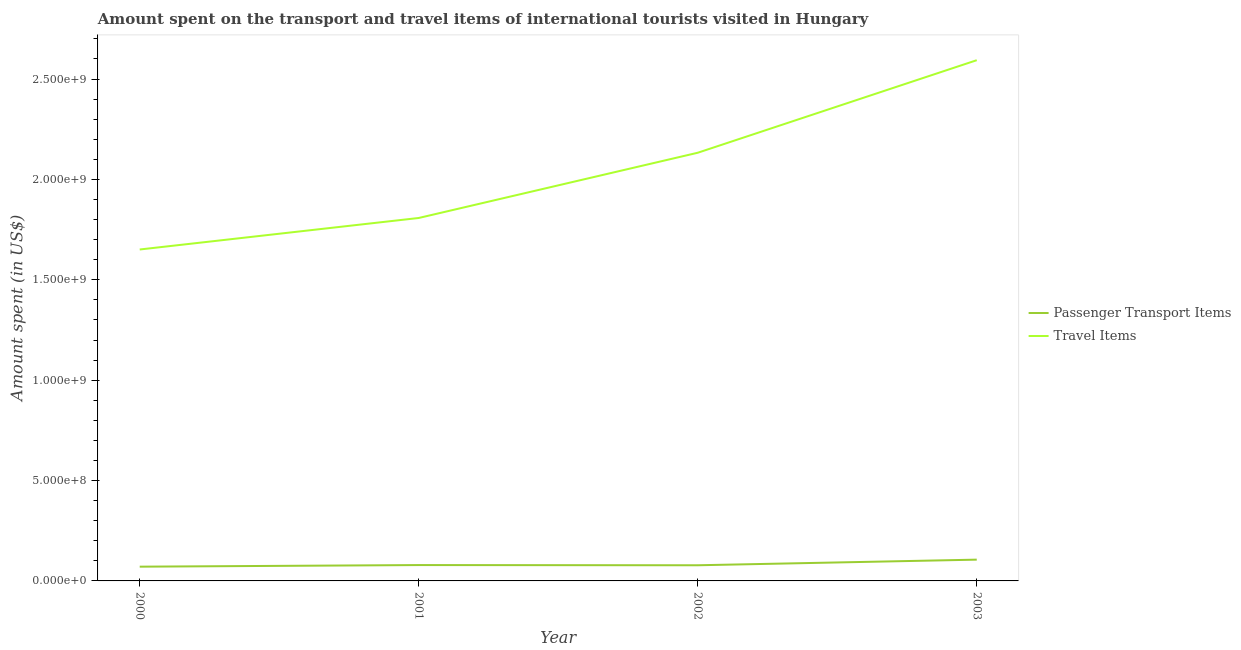Does the line corresponding to amount spent in travel items intersect with the line corresponding to amount spent on passenger transport items?
Provide a short and direct response. No. Is the number of lines equal to the number of legend labels?
Your answer should be compact. Yes. What is the amount spent on passenger transport items in 2002?
Provide a succinct answer. 7.80e+07. Across all years, what is the maximum amount spent on passenger transport items?
Offer a terse response. 1.06e+08. Across all years, what is the minimum amount spent in travel items?
Offer a terse response. 1.65e+09. In which year was the amount spent in travel items minimum?
Your answer should be very brief. 2000. What is the total amount spent on passenger transport items in the graph?
Your answer should be very brief. 3.34e+08. What is the difference between the amount spent on passenger transport items in 2002 and that in 2003?
Offer a terse response. -2.80e+07. What is the difference between the amount spent on passenger transport items in 2002 and the amount spent in travel items in 2000?
Offer a very short reply. -1.57e+09. What is the average amount spent on passenger transport items per year?
Ensure brevity in your answer.  8.35e+07. In the year 2000, what is the difference between the amount spent on passenger transport items and amount spent in travel items?
Your answer should be compact. -1.58e+09. What is the ratio of the amount spent in travel items in 2000 to that in 2001?
Provide a succinct answer. 0.91. Is the amount spent on passenger transport items in 2000 less than that in 2002?
Keep it short and to the point. Yes. What is the difference between the highest and the second highest amount spent on passenger transport items?
Your response must be concise. 2.70e+07. What is the difference between the highest and the lowest amount spent in travel items?
Keep it short and to the point. 9.43e+08. How many years are there in the graph?
Your response must be concise. 4. What is the difference between two consecutive major ticks on the Y-axis?
Your answer should be very brief. 5.00e+08. Are the values on the major ticks of Y-axis written in scientific E-notation?
Provide a succinct answer. Yes. Does the graph contain any zero values?
Ensure brevity in your answer.  No. Does the graph contain grids?
Give a very brief answer. No. How are the legend labels stacked?
Give a very brief answer. Vertical. What is the title of the graph?
Offer a very short reply. Amount spent on the transport and travel items of international tourists visited in Hungary. Does "Investment" appear as one of the legend labels in the graph?
Offer a very short reply. No. What is the label or title of the X-axis?
Make the answer very short. Year. What is the label or title of the Y-axis?
Your answer should be compact. Amount spent (in US$). What is the Amount spent (in US$) in Passenger Transport Items in 2000?
Offer a very short reply. 7.10e+07. What is the Amount spent (in US$) in Travel Items in 2000?
Make the answer very short. 1.65e+09. What is the Amount spent (in US$) in Passenger Transport Items in 2001?
Your answer should be very brief. 7.90e+07. What is the Amount spent (in US$) in Travel Items in 2001?
Provide a short and direct response. 1.81e+09. What is the Amount spent (in US$) of Passenger Transport Items in 2002?
Offer a terse response. 7.80e+07. What is the Amount spent (in US$) of Travel Items in 2002?
Ensure brevity in your answer.  2.13e+09. What is the Amount spent (in US$) of Passenger Transport Items in 2003?
Offer a terse response. 1.06e+08. What is the Amount spent (in US$) in Travel Items in 2003?
Offer a terse response. 2.59e+09. Across all years, what is the maximum Amount spent (in US$) in Passenger Transport Items?
Your answer should be compact. 1.06e+08. Across all years, what is the maximum Amount spent (in US$) in Travel Items?
Ensure brevity in your answer.  2.59e+09. Across all years, what is the minimum Amount spent (in US$) in Passenger Transport Items?
Ensure brevity in your answer.  7.10e+07. Across all years, what is the minimum Amount spent (in US$) of Travel Items?
Give a very brief answer. 1.65e+09. What is the total Amount spent (in US$) in Passenger Transport Items in the graph?
Your answer should be very brief. 3.34e+08. What is the total Amount spent (in US$) in Travel Items in the graph?
Make the answer very short. 8.19e+09. What is the difference between the Amount spent (in US$) of Passenger Transport Items in 2000 and that in 2001?
Your response must be concise. -8.00e+06. What is the difference between the Amount spent (in US$) in Travel Items in 2000 and that in 2001?
Ensure brevity in your answer.  -1.57e+08. What is the difference between the Amount spent (in US$) of Passenger Transport Items in 2000 and that in 2002?
Provide a short and direct response. -7.00e+06. What is the difference between the Amount spent (in US$) of Travel Items in 2000 and that in 2002?
Your answer should be compact. -4.82e+08. What is the difference between the Amount spent (in US$) of Passenger Transport Items in 2000 and that in 2003?
Offer a very short reply. -3.50e+07. What is the difference between the Amount spent (in US$) of Travel Items in 2000 and that in 2003?
Your answer should be very brief. -9.43e+08. What is the difference between the Amount spent (in US$) in Travel Items in 2001 and that in 2002?
Offer a terse response. -3.25e+08. What is the difference between the Amount spent (in US$) in Passenger Transport Items in 2001 and that in 2003?
Provide a succinct answer. -2.70e+07. What is the difference between the Amount spent (in US$) of Travel Items in 2001 and that in 2003?
Make the answer very short. -7.86e+08. What is the difference between the Amount spent (in US$) in Passenger Transport Items in 2002 and that in 2003?
Make the answer very short. -2.80e+07. What is the difference between the Amount spent (in US$) in Travel Items in 2002 and that in 2003?
Offer a terse response. -4.61e+08. What is the difference between the Amount spent (in US$) in Passenger Transport Items in 2000 and the Amount spent (in US$) in Travel Items in 2001?
Your answer should be very brief. -1.74e+09. What is the difference between the Amount spent (in US$) in Passenger Transport Items in 2000 and the Amount spent (in US$) in Travel Items in 2002?
Your answer should be very brief. -2.06e+09. What is the difference between the Amount spent (in US$) in Passenger Transport Items in 2000 and the Amount spent (in US$) in Travel Items in 2003?
Offer a terse response. -2.52e+09. What is the difference between the Amount spent (in US$) of Passenger Transport Items in 2001 and the Amount spent (in US$) of Travel Items in 2002?
Your response must be concise. -2.05e+09. What is the difference between the Amount spent (in US$) of Passenger Transport Items in 2001 and the Amount spent (in US$) of Travel Items in 2003?
Ensure brevity in your answer.  -2.52e+09. What is the difference between the Amount spent (in US$) of Passenger Transport Items in 2002 and the Amount spent (in US$) of Travel Items in 2003?
Keep it short and to the point. -2.52e+09. What is the average Amount spent (in US$) in Passenger Transport Items per year?
Provide a short and direct response. 8.35e+07. What is the average Amount spent (in US$) in Travel Items per year?
Your response must be concise. 2.05e+09. In the year 2000, what is the difference between the Amount spent (in US$) in Passenger Transport Items and Amount spent (in US$) in Travel Items?
Your answer should be compact. -1.58e+09. In the year 2001, what is the difference between the Amount spent (in US$) in Passenger Transport Items and Amount spent (in US$) in Travel Items?
Provide a succinct answer. -1.73e+09. In the year 2002, what is the difference between the Amount spent (in US$) in Passenger Transport Items and Amount spent (in US$) in Travel Items?
Provide a short and direct response. -2.06e+09. In the year 2003, what is the difference between the Amount spent (in US$) in Passenger Transport Items and Amount spent (in US$) in Travel Items?
Give a very brief answer. -2.49e+09. What is the ratio of the Amount spent (in US$) of Passenger Transport Items in 2000 to that in 2001?
Make the answer very short. 0.9. What is the ratio of the Amount spent (in US$) in Travel Items in 2000 to that in 2001?
Keep it short and to the point. 0.91. What is the ratio of the Amount spent (in US$) in Passenger Transport Items in 2000 to that in 2002?
Make the answer very short. 0.91. What is the ratio of the Amount spent (in US$) of Travel Items in 2000 to that in 2002?
Offer a very short reply. 0.77. What is the ratio of the Amount spent (in US$) in Passenger Transport Items in 2000 to that in 2003?
Your answer should be very brief. 0.67. What is the ratio of the Amount spent (in US$) of Travel Items in 2000 to that in 2003?
Give a very brief answer. 0.64. What is the ratio of the Amount spent (in US$) of Passenger Transport Items in 2001 to that in 2002?
Ensure brevity in your answer.  1.01. What is the ratio of the Amount spent (in US$) of Travel Items in 2001 to that in 2002?
Your answer should be compact. 0.85. What is the ratio of the Amount spent (in US$) in Passenger Transport Items in 2001 to that in 2003?
Give a very brief answer. 0.75. What is the ratio of the Amount spent (in US$) of Travel Items in 2001 to that in 2003?
Make the answer very short. 0.7. What is the ratio of the Amount spent (in US$) in Passenger Transport Items in 2002 to that in 2003?
Ensure brevity in your answer.  0.74. What is the ratio of the Amount spent (in US$) of Travel Items in 2002 to that in 2003?
Offer a very short reply. 0.82. What is the difference between the highest and the second highest Amount spent (in US$) of Passenger Transport Items?
Offer a very short reply. 2.70e+07. What is the difference between the highest and the second highest Amount spent (in US$) in Travel Items?
Your answer should be compact. 4.61e+08. What is the difference between the highest and the lowest Amount spent (in US$) of Passenger Transport Items?
Your response must be concise. 3.50e+07. What is the difference between the highest and the lowest Amount spent (in US$) of Travel Items?
Your answer should be very brief. 9.43e+08. 